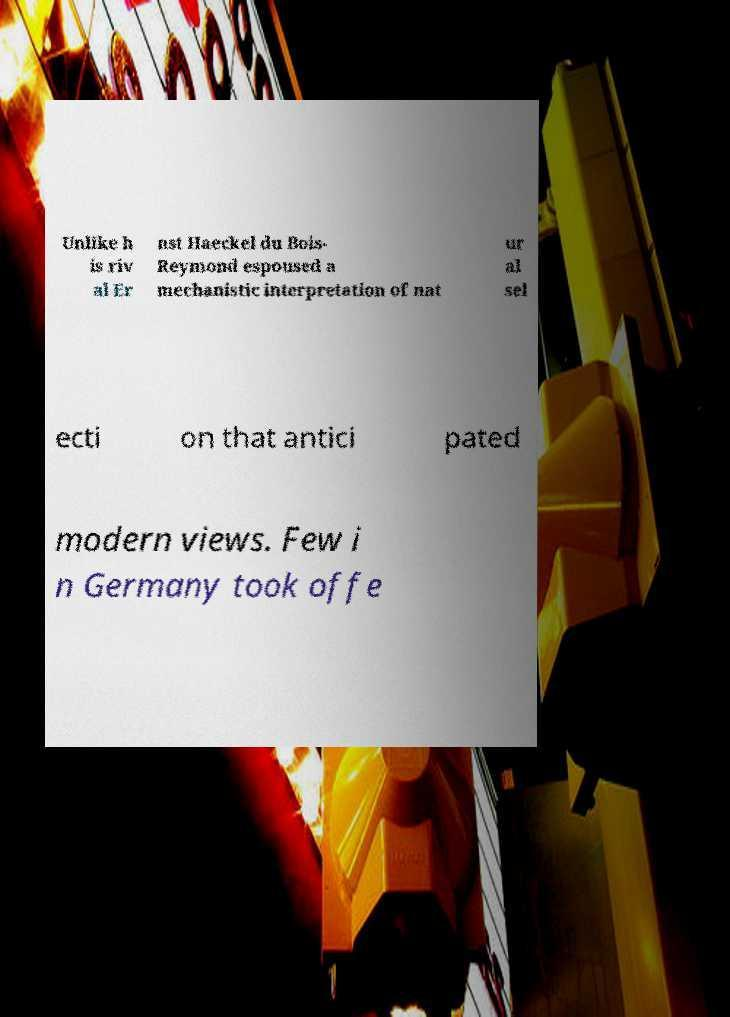Could you assist in decoding the text presented in this image and type it out clearly? Unlike h is riv al Er nst Haeckel du Bois- Reymond espoused a mechanistic interpretation of nat ur al sel ecti on that antici pated modern views. Few i n Germany took offe 